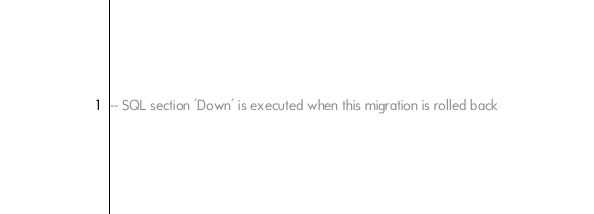<code> <loc_0><loc_0><loc_500><loc_500><_SQL_>-- SQL section 'Down' is executed when this migration is rolled back

</code> 